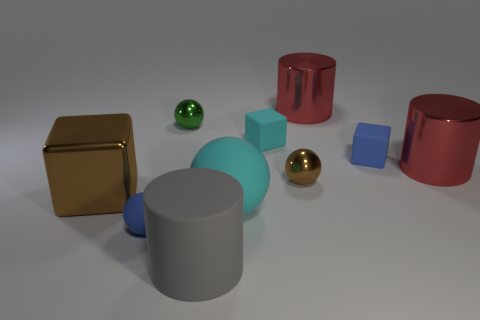Subtract all large red cylinders. How many cylinders are left? 1 Subtract 1 cubes. How many cubes are left? 2 Subtract all gray balls. How many red cylinders are left? 2 Subtract all spheres. How many objects are left? 6 Subtract all gray cylinders. How many cylinders are left? 2 Add 3 big spheres. How many big spheres exist? 4 Subtract 1 blue spheres. How many objects are left? 9 Subtract all gray cylinders. Subtract all brown blocks. How many cylinders are left? 2 Subtract all small cyan balls. Subtract all small blue matte things. How many objects are left? 8 Add 5 metallic objects. How many metallic objects are left? 10 